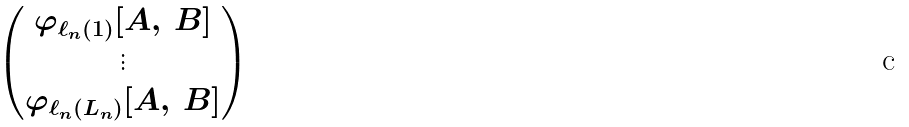Convert formula to latex. <formula><loc_0><loc_0><loc_500><loc_500>\begin{pmatrix} \varphi _ { \ell _ { n } ( 1 ) } [ A , \, B ] \\ \vdots \\ \varphi _ { \ell _ { n } ( L _ { n } ) } [ A , \, B ] \end{pmatrix}</formula> 